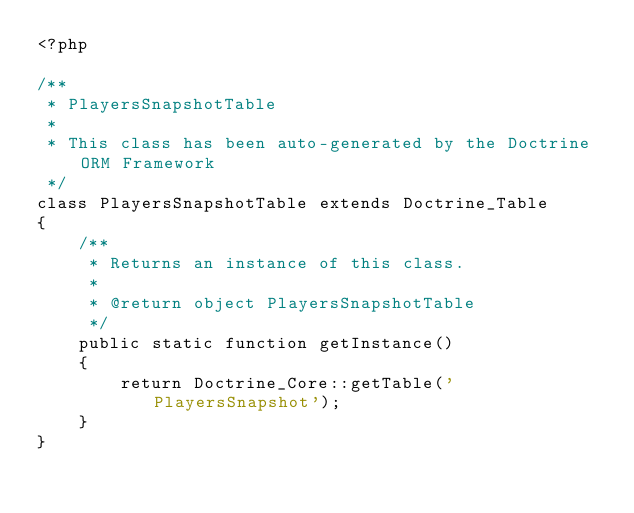<code> <loc_0><loc_0><loc_500><loc_500><_PHP_><?php

/**
 * PlayersSnapshotTable
 * 
 * This class has been auto-generated by the Doctrine ORM Framework
 */
class PlayersSnapshotTable extends Doctrine_Table
{
    /**
     * Returns an instance of this class.
     *
     * @return object PlayersSnapshotTable
     */
    public static function getInstance()
    {
        return Doctrine_Core::getTable('PlayersSnapshot');
    }
}</code> 